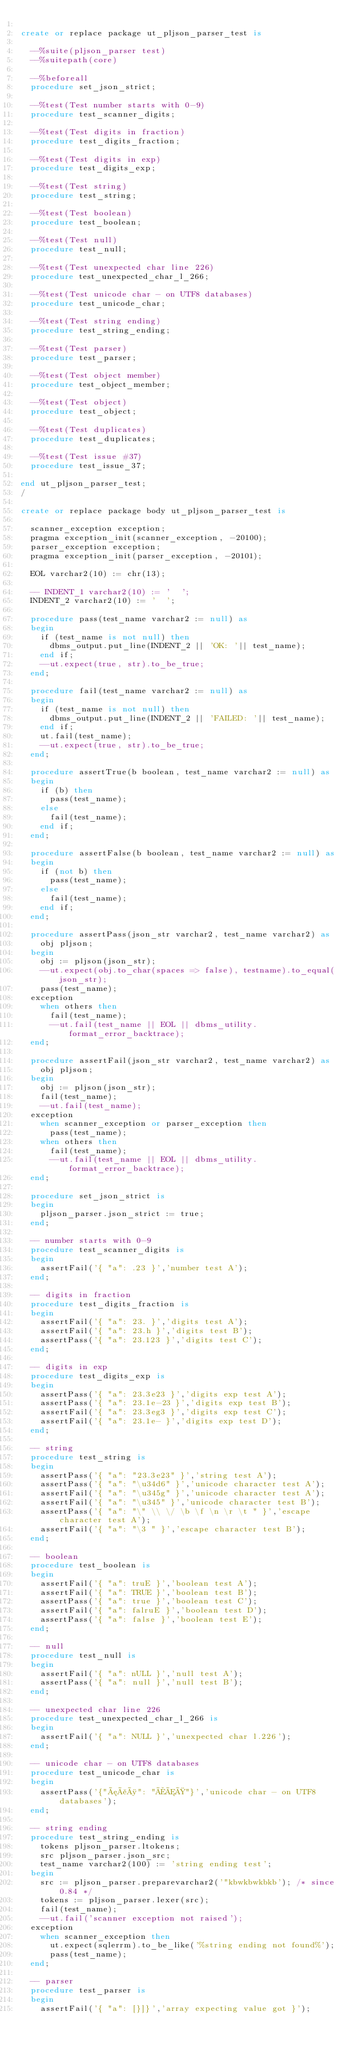Convert code to text. <code><loc_0><loc_0><loc_500><loc_500><_SQL_>
create or replace package ut_pljson_parser_test is
  
  --%suite(pljson_parser test)
  --%suitepath(core)
  
  --%beforeall
  procedure set_json_strict;
  
  --%test(Test number starts with 0-9)
  procedure test_scanner_digits;
  
  --%test(Test digits in fraction)
  procedure test_digits_fraction;
  
  --%test(Test digits in exp)
  procedure test_digits_exp;
  
  --%test(Test string)
  procedure test_string;
  
  --%test(Test boolean)
  procedure test_boolean;
  
  --%test(Test null)
  procedure test_null;
  
  --%test(Test unexpected char line 226)
  procedure test_unexpected_char_l_266;
  
  --%test(Test unicode char - on UTF8 databases)
  procedure test_unicode_char;
  
  --%test(Test string ending)
  procedure test_string_ending;
  
  --%test(Test parser)
  procedure test_parser;
  
  --%test(Test object member)
  procedure test_object_member;
  
  --%test(Test object)
  procedure test_object;
  
  --%test(Test duplicates)
  procedure test_duplicates;
  
  --%test(Test issue #37)
  procedure test_issue_37;
  
end ut_pljson_parser_test;
/

create or replace package body ut_pljson_parser_test is
  
  scanner_exception exception;
  pragma exception_init(scanner_exception, -20100);
  parser_exception exception;
  pragma exception_init(parser_exception, -20101);
  
  EOL varchar2(10) := chr(13);
  
  -- INDENT_1 varchar2(10) := '  ';
  INDENT_2 varchar2(10) := '  ';
  
  procedure pass(test_name varchar2 := null) as
  begin
    if (test_name is not null) then
      dbms_output.put_line(INDENT_2 || 'OK: '|| test_name);
    end if;
    --ut.expect(true, str).to_be_true;
  end;
  
  procedure fail(test_name varchar2 := null) as
  begin
    if (test_name is not null) then
      dbms_output.put_line(INDENT_2 || 'FAILED: '|| test_name);
    end if;
    ut.fail(test_name);
    --ut.expect(true, str).to_be_true;
  end;
  
  procedure assertTrue(b boolean, test_name varchar2 := null) as
  begin
    if (b) then
      pass(test_name);
    else
      fail(test_name);
    end if;
  end;
  
  procedure assertFalse(b boolean, test_name varchar2 := null) as
  begin
    if (not b) then
      pass(test_name);
    else
      fail(test_name);
    end if;
  end;
  
  procedure assertPass(json_str varchar2, test_name varchar2) as
    obj pljson;
  begin
    obj := pljson(json_str);
    --ut.expect(obj.to_char(spaces => false), testname).to_equal(json_str);
    pass(test_name);
  exception
    when others then
      fail(test_name);
      --ut.fail(test_name || EOL || dbms_utility.format_error_backtrace);
  end;
  
  procedure assertFail(json_str varchar2, test_name varchar2) as
    obj pljson;
  begin
    obj := pljson(json_str);
    fail(test_name);
    --ut.fail(test_name);
  exception
    when scanner_exception or parser_exception then
      pass(test_name);
    when others then
      fail(test_name);
      --ut.fail(test_name || EOL || dbms_utility.format_error_backtrace);
  end;
  
  procedure set_json_strict is
  begin
    pljson_parser.json_strict := true;
  end;
  
  -- number starts with 0-9
  procedure test_scanner_digits is
  begin
    assertFail('{ "a": .23 }','number test A');
  end;
  
  -- digits in fraction
  procedure test_digits_fraction is
  begin
    assertFail('{ "a": 23. }','digits test A');
    assertFail('{ "a": 23.h }','digits test B');
    assertPass('{ "a": 23.123 }','digits test C');
  end;
  
  -- digits in exp
  procedure test_digits_exp is
  begin
    assertPass('{ "a": 23.3e23 }','digits exp test A');
    assertPass('{ "a": 23.1e-23 }','digits exp test B');
    assertFail('{ "a": 23.3eg3 }','digits exp test C');
    assertFail('{ "a": 23.1e- }','digits exp test D');
  end;  
  
  -- string
  procedure test_string is
  begin
    assertPass('{ "a": "23.3e23" }','string test A');
    assertPass('{ "a": "\u34d6" }','unicode character test A');
    assertFail('{ "a": "\u345g" }','unicode character test A');
    assertFail('{ "a": "\u345" }','unicode character test B');
    assertPass('{ "a": "\" \\ \/ \b \f \n \r \t " }','escape character test A');
    assertFail('{ "a": "\3 " }','escape character test B');
  end;
  
  -- boolean
  procedure test_boolean is
  begin
    assertFail('{ "a": truE }','boolean test A');
    assertFail('{ "a": TRUE }','boolean test B');
    assertPass('{ "a": true }','boolean test C');
    assertFail('{ "a": falruE }','boolean test D');
    assertPass('{ "a": false }','boolean test E');
  end;
  
  -- null
  procedure test_null is
  begin
    assertFail('{ "a": nULL }','null test A');
    assertPass('{ "a": null }','null test B');
  end;
  
  -- unexpected char line 226
  procedure test_unexpected_char_l_266 is
  begin
    assertFail('{ "a": NULL }','unexpected char l.226');
  end;
  
  -- unicode char - on UTF8 databases
  procedure test_unicode_char is
  begin
    assertPass('{"æåø": "ÅÆØ"}','unicode char - on UTF8 databases');
  end;
  
  -- string ending
  procedure test_string_ending is
    tokens pljson_parser.ltokens;
    src pljson_parser.json_src;
    test_name varchar2(100) := 'string ending test';
  begin
    src := pljson_parser.preparevarchar2('"kbwkbwkbkb'); /* since 0.84 */
    tokens := pljson_parser.lexer(src);
    fail(test_name);
    --ut.fail('scanner exception not raised');
  exception
    when scanner_exception then
      ut.expect(sqlerrm).to_be_like('%string ending not found%');
      pass(test_name);
  end;
  
  -- parser
  procedure test_parser is
  begin
    assertFail('{ "a": [}]}','array expecting value got }');</code> 